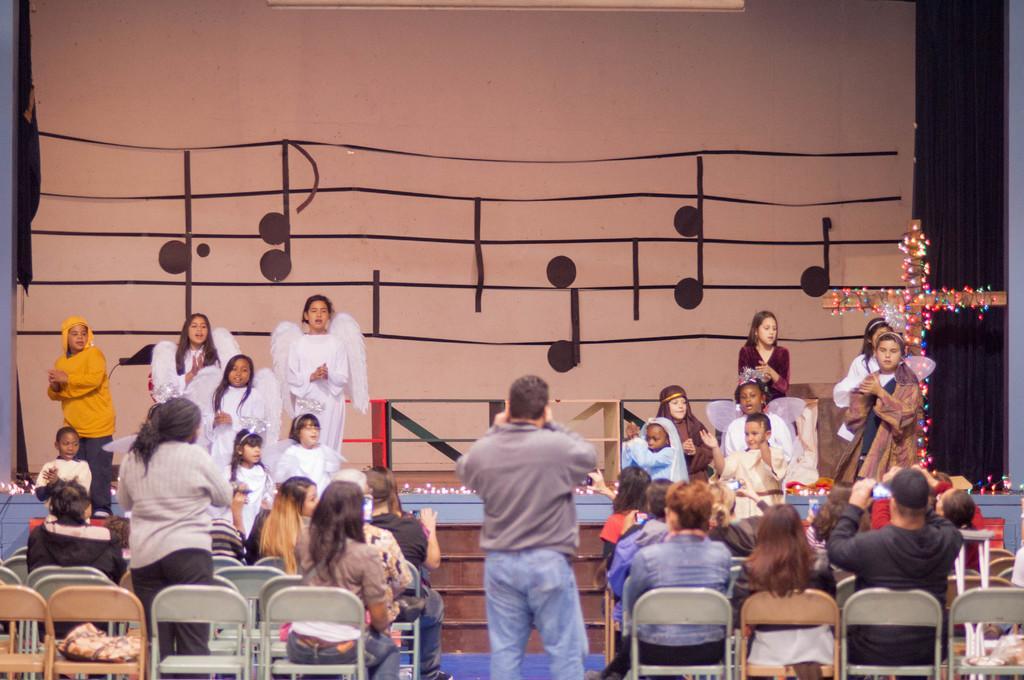Can you describe this image briefly? In this picture I can see there are few kids standing on the dais and there are few people sitting in the chairs here and there is a person clicking the picture. 